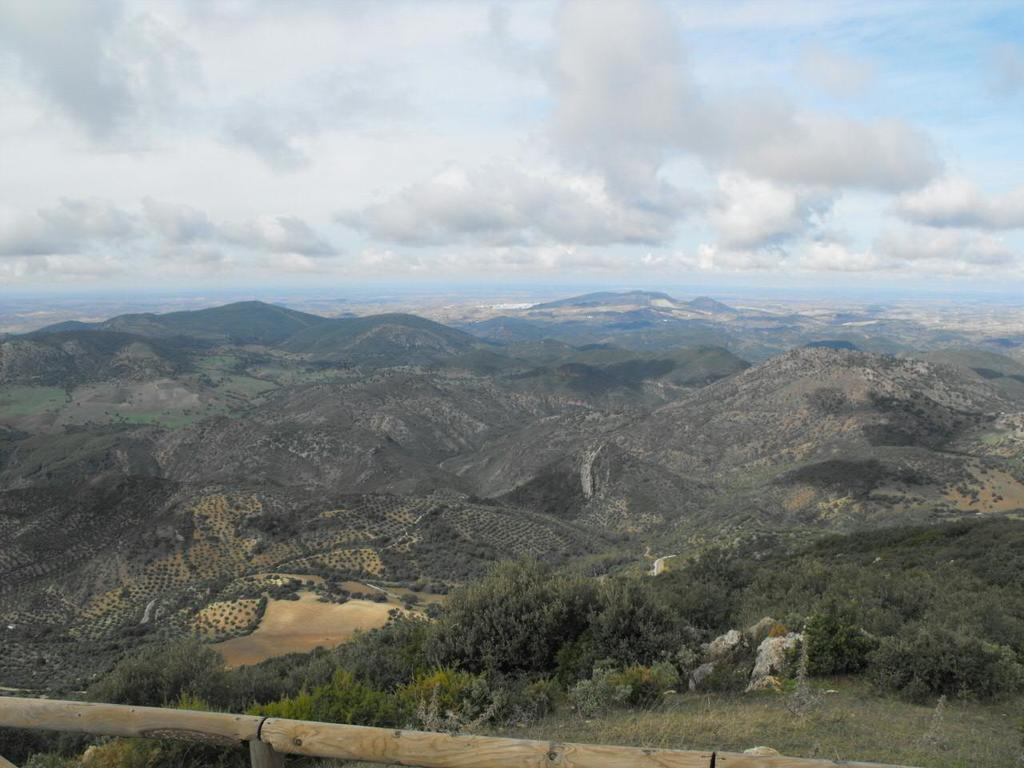What type of natural environment is depicted in the image? There is greenery in the image, suggesting a natural setting. What geographical features can be seen in the background of the image? There are mountains visible in the background of the image. How would you describe the weather in the image? The sky is cloudy in the image, indicating possible overcast or rainy conditions. What type of trade is happening between the drum and the club in the image? There is no drum or club present in the image; the facts provided only mention greenery, mountains, and a cloudy sky. 